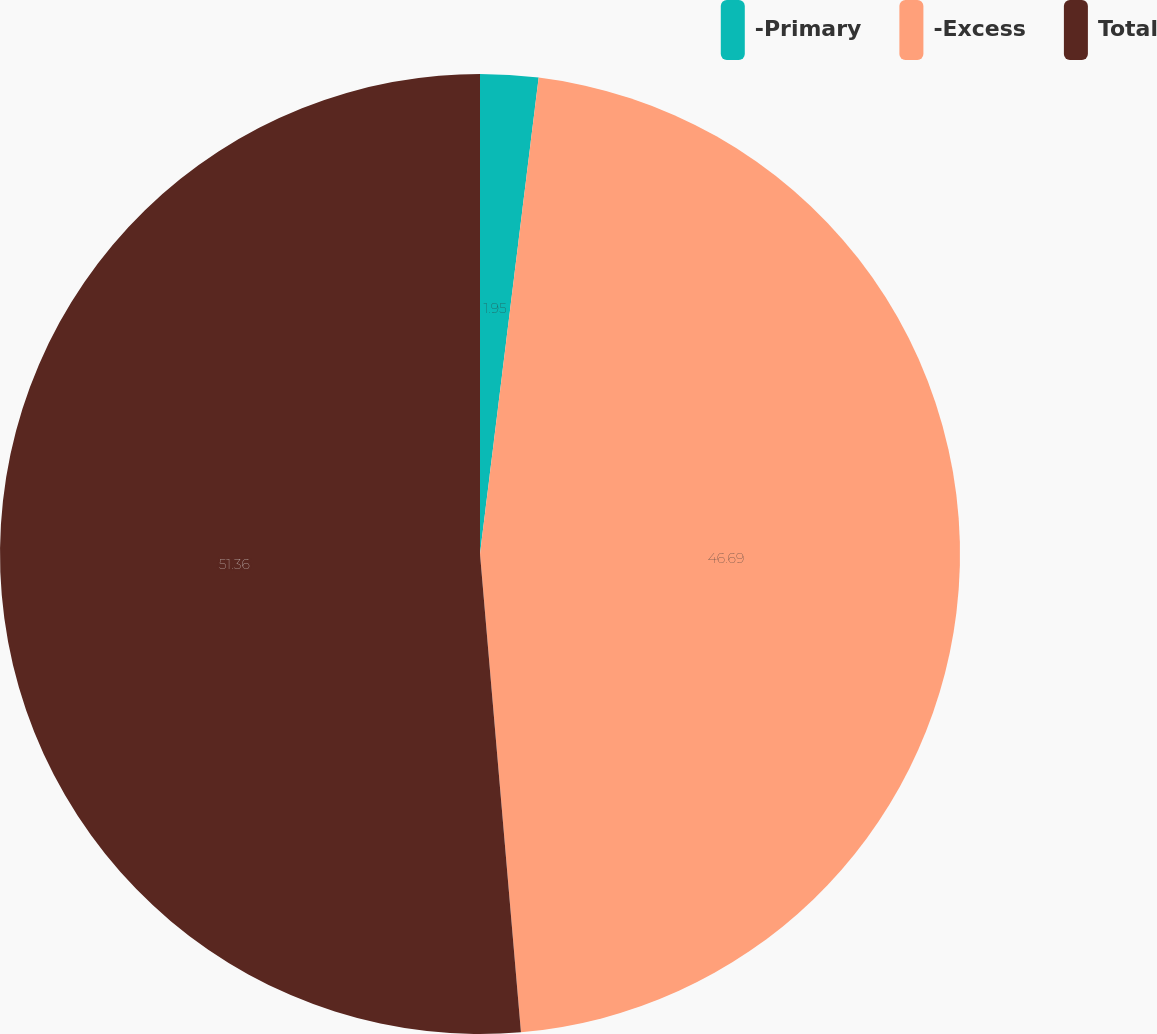Convert chart. <chart><loc_0><loc_0><loc_500><loc_500><pie_chart><fcel>-Primary<fcel>-Excess<fcel>Total<nl><fcel>1.95%<fcel>46.69%<fcel>51.36%<nl></chart> 